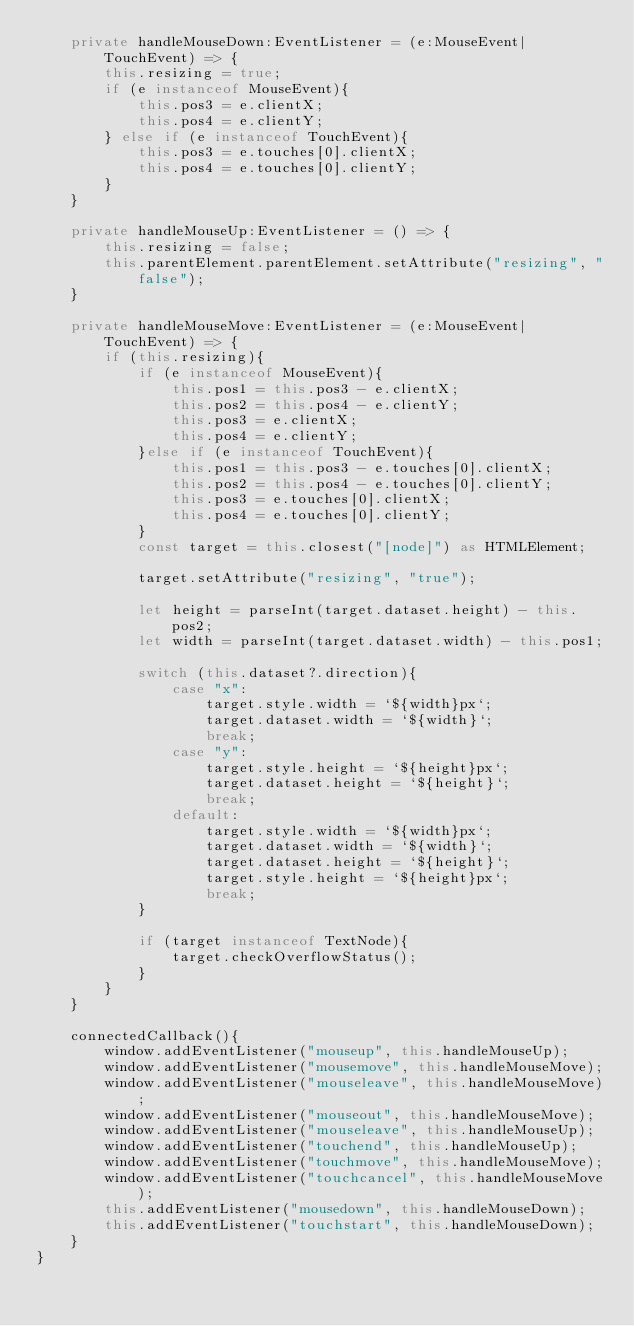Convert code to text. <code><loc_0><loc_0><loc_500><loc_500><_TypeScript_>    private handleMouseDown:EventListener = (e:MouseEvent|TouchEvent) => {
        this.resizing = true;
        if (e instanceof MouseEvent){
            this.pos3 = e.clientX;
            this.pos4 = e.clientY;
        } else if (e instanceof TouchEvent){
            this.pos3 = e.touches[0].clientX;
            this.pos4 = e.touches[0].clientY;
        }
    }

    private handleMouseUp:EventListener = () => {
        this.resizing = false;
        this.parentElement.parentElement.setAttribute("resizing", "false");
    }

    private handleMouseMove:EventListener = (e:MouseEvent|TouchEvent) => {
        if (this.resizing){
            if (e instanceof MouseEvent){
                this.pos1 = this.pos3 - e.clientX;
                this.pos2 = this.pos4 - e.clientY;
                this.pos3 = e.clientX;
                this.pos4 = e.clientY;
            }else if (e instanceof TouchEvent){
                this.pos1 = this.pos3 - e.touches[0].clientX;
                this.pos2 = this.pos4 - e.touches[0].clientY;
                this.pos3 = e.touches[0].clientX;
                this.pos4 = e.touches[0].clientY;
            }
            const target = this.closest("[node]") as HTMLElement;

            target.setAttribute("resizing", "true");

            let height = parseInt(target.dataset.height) - this.pos2;
            let width = parseInt(target.dataset.width) - this.pos1;

            switch (this.dataset?.direction){
                case "x":
                    target.style.width = `${width}px`;
                    target.dataset.width = `${width}`;
                    break;
                case "y":
                    target.style.height = `${height}px`;
                    target.dataset.height = `${height}`;
                    break;
                default:
                    target.style.width = `${width}px`;
                    target.dataset.width = `${width}`;
                    target.dataset.height = `${height}`;
                    target.style.height = `${height}px`;
                    break;
            }

            if (target instanceof TextNode){
                target.checkOverflowStatus();
            }
        }
    }

    connectedCallback(){        
        window.addEventListener("mouseup", this.handleMouseUp);
        window.addEventListener("mousemove", this.handleMouseMove);
        window.addEventListener("mouseleave", this.handleMouseMove);
        window.addEventListener("mouseout", this.handleMouseMove);
        window.addEventListener("mouseleave", this.handleMouseUp);
        window.addEventListener("touchend", this.handleMouseUp);
        window.addEventListener("touchmove", this.handleMouseMove);
        window.addEventListener("touchcancel", this.handleMouseMove);
        this.addEventListener("mousedown", this.handleMouseDown);
        this.addEventListener("touchstart", this.handleMouseDown);
    }
}
</code> 